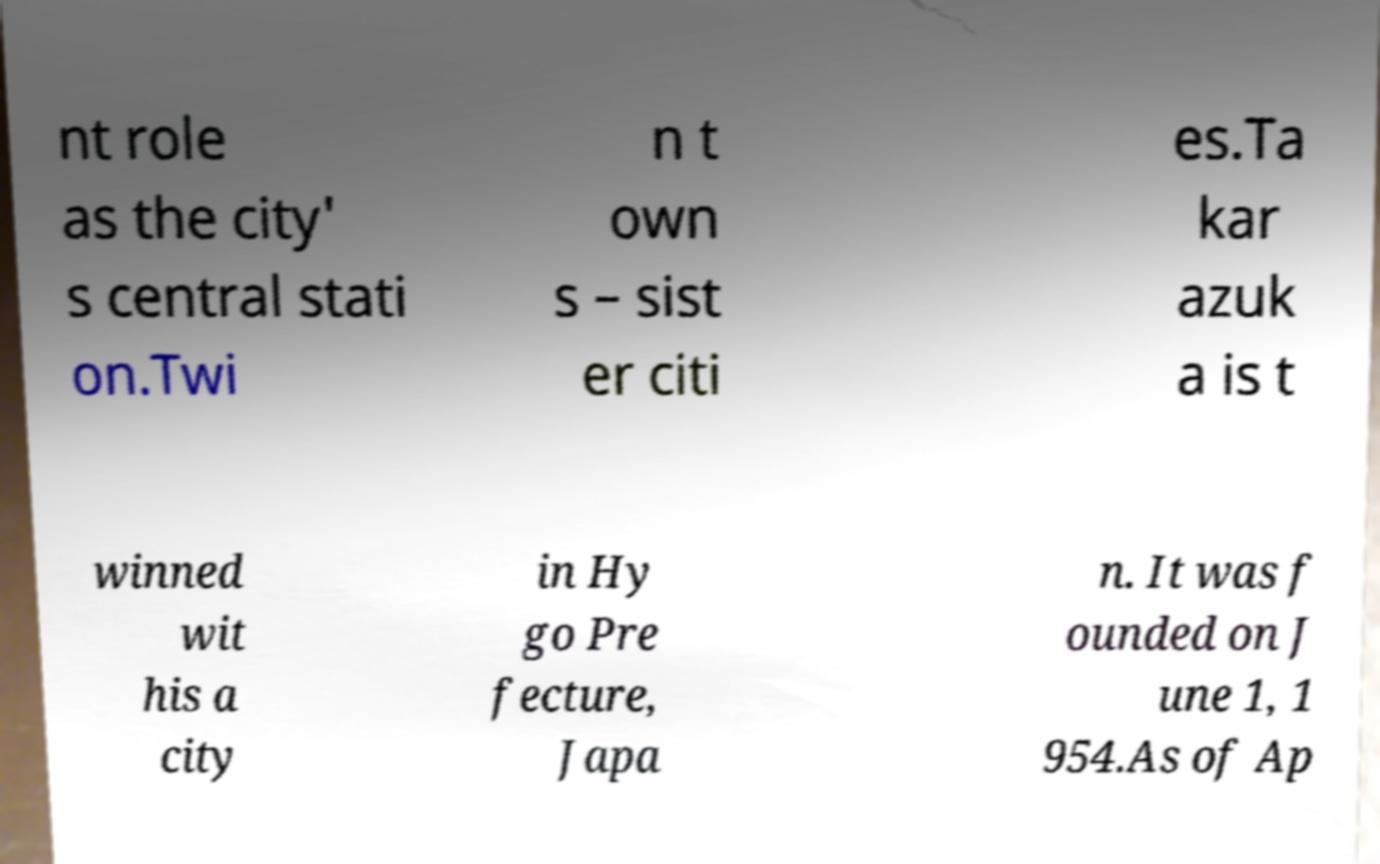Could you assist in decoding the text presented in this image and type it out clearly? nt role as the city' s central stati on.Twi n t own s – sist er citi es.Ta kar azuk a is t winned wit his a city in Hy go Pre fecture, Japa n. It was f ounded on J une 1, 1 954.As of Ap 